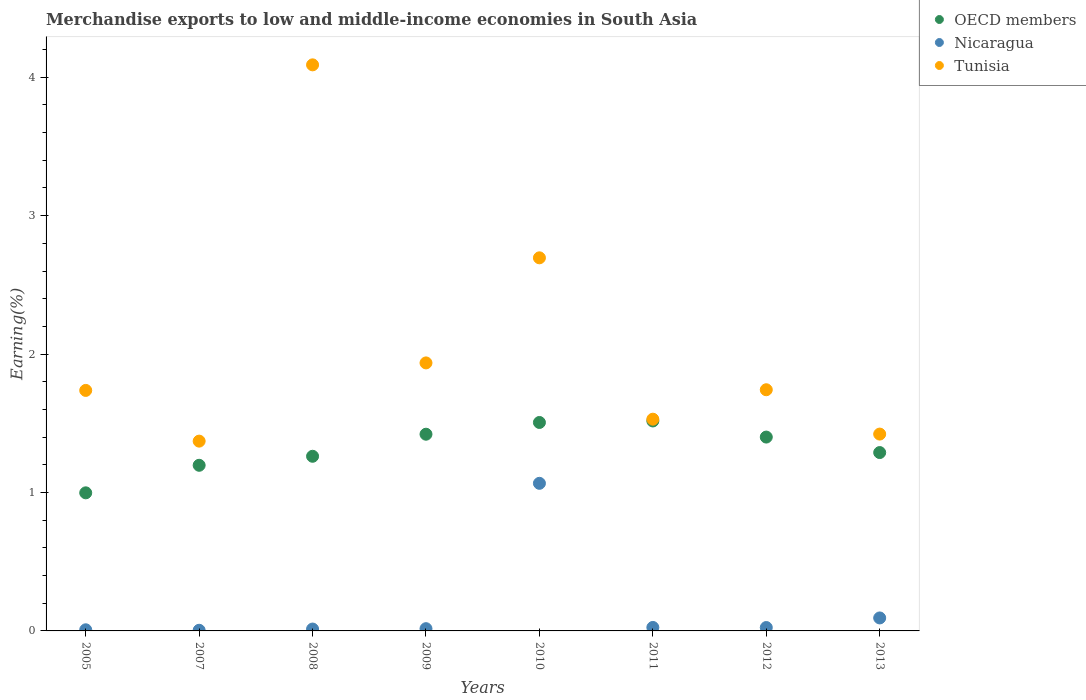How many different coloured dotlines are there?
Your answer should be compact. 3. Is the number of dotlines equal to the number of legend labels?
Keep it short and to the point. Yes. What is the percentage of amount earned from merchandise exports in Nicaragua in 2011?
Your answer should be very brief. 0.03. Across all years, what is the maximum percentage of amount earned from merchandise exports in Tunisia?
Offer a terse response. 4.09. Across all years, what is the minimum percentage of amount earned from merchandise exports in Tunisia?
Offer a terse response. 1.37. What is the total percentage of amount earned from merchandise exports in Nicaragua in the graph?
Offer a very short reply. 1.25. What is the difference between the percentage of amount earned from merchandise exports in OECD members in 2011 and that in 2012?
Provide a succinct answer. 0.12. What is the difference between the percentage of amount earned from merchandise exports in OECD members in 2007 and the percentage of amount earned from merchandise exports in Nicaragua in 2009?
Offer a terse response. 1.18. What is the average percentage of amount earned from merchandise exports in OECD members per year?
Make the answer very short. 1.32. In the year 2005, what is the difference between the percentage of amount earned from merchandise exports in Tunisia and percentage of amount earned from merchandise exports in Nicaragua?
Provide a succinct answer. 1.73. What is the ratio of the percentage of amount earned from merchandise exports in Tunisia in 2009 to that in 2013?
Offer a very short reply. 1.36. Is the difference between the percentage of amount earned from merchandise exports in Tunisia in 2009 and 2013 greater than the difference between the percentage of amount earned from merchandise exports in Nicaragua in 2009 and 2013?
Offer a terse response. Yes. What is the difference between the highest and the second highest percentage of amount earned from merchandise exports in Tunisia?
Provide a short and direct response. 1.39. What is the difference between the highest and the lowest percentage of amount earned from merchandise exports in OECD members?
Keep it short and to the point. 0.52. Does the percentage of amount earned from merchandise exports in Tunisia monotonically increase over the years?
Make the answer very short. No. Is the percentage of amount earned from merchandise exports in OECD members strictly greater than the percentage of amount earned from merchandise exports in Nicaragua over the years?
Your answer should be compact. Yes. Is the percentage of amount earned from merchandise exports in Nicaragua strictly less than the percentage of amount earned from merchandise exports in OECD members over the years?
Give a very brief answer. Yes. How many dotlines are there?
Offer a terse response. 3. How many years are there in the graph?
Your response must be concise. 8. Are the values on the major ticks of Y-axis written in scientific E-notation?
Make the answer very short. No. Does the graph contain any zero values?
Make the answer very short. No. How many legend labels are there?
Make the answer very short. 3. What is the title of the graph?
Keep it short and to the point. Merchandise exports to low and middle-income economies in South Asia. Does "France" appear as one of the legend labels in the graph?
Provide a short and direct response. No. What is the label or title of the X-axis?
Your answer should be compact. Years. What is the label or title of the Y-axis?
Ensure brevity in your answer.  Earning(%). What is the Earning(%) in OECD members in 2005?
Keep it short and to the point. 1. What is the Earning(%) of Nicaragua in 2005?
Your answer should be very brief. 0.01. What is the Earning(%) in Tunisia in 2005?
Ensure brevity in your answer.  1.74. What is the Earning(%) of OECD members in 2007?
Offer a very short reply. 1.2. What is the Earning(%) of Nicaragua in 2007?
Your answer should be compact. 0. What is the Earning(%) of Tunisia in 2007?
Make the answer very short. 1.37. What is the Earning(%) of OECD members in 2008?
Keep it short and to the point. 1.26. What is the Earning(%) of Nicaragua in 2008?
Provide a short and direct response. 0.01. What is the Earning(%) of Tunisia in 2008?
Offer a very short reply. 4.09. What is the Earning(%) of OECD members in 2009?
Ensure brevity in your answer.  1.42. What is the Earning(%) in Nicaragua in 2009?
Offer a terse response. 0.02. What is the Earning(%) in Tunisia in 2009?
Offer a very short reply. 1.94. What is the Earning(%) in OECD members in 2010?
Make the answer very short. 1.51. What is the Earning(%) of Nicaragua in 2010?
Make the answer very short. 1.07. What is the Earning(%) in Tunisia in 2010?
Make the answer very short. 2.7. What is the Earning(%) of OECD members in 2011?
Provide a succinct answer. 1.52. What is the Earning(%) in Nicaragua in 2011?
Give a very brief answer. 0.03. What is the Earning(%) in Tunisia in 2011?
Your response must be concise. 1.53. What is the Earning(%) of OECD members in 2012?
Give a very brief answer. 1.4. What is the Earning(%) in Nicaragua in 2012?
Ensure brevity in your answer.  0.02. What is the Earning(%) of Tunisia in 2012?
Your answer should be very brief. 1.74. What is the Earning(%) in OECD members in 2013?
Give a very brief answer. 1.29. What is the Earning(%) in Nicaragua in 2013?
Make the answer very short. 0.09. What is the Earning(%) in Tunisia in 2013?
Provide a short and direct response. 1.42. Across all years, what is the maximum Earning(%) in OECD members?
Offer a very short reply. 1.52. Across all years, what is the maximum Earning(%) in Nicaragua?
Your response must be concise. 1.07. Across all years, what is the maximum Earning(%) of Tunisia?
Offer a terse response. 4.09. Across all years, what is the minimum Earning(%) in OECD members?
Provide a short and direct response. 1. Across all years, what is the minimum Earning(%) in Nicaragua?
Give a very brief answer. 0. Across all years, what is the minimum Earning(%) of Tunisia?
Make the answer very short. 1.37. What is the total Earning(%) of OECD members in the graph?
Keep it short and to the point. 10.59. What is the total Earning(%) of Nicaragua in the graph?
Give a very brief answer. 1.25. What is the total Earning(%) in Tunisia in the graph?
Make the answer very short. 16.52. What is the difference between the Earning(%) of OECD members in 2005 and that in 2007?
Provide a succinct answer. -0.2. What is the difference between the Earning(%) in Nicaragua in 2005 and that in 2007?
Give a very brief answer. 0. What is the difference between the Earning(%) of Tunisia in 2005 and that in 2007?
Keep it short and to the point. 0.37. What is the difference between the Earning(%) in OECD members in 2005 and that in 2008?
Your answer should be compact. -0.26. What is the difference between the Earning(%) of Nicaragua in 2005 and that in 2008?
Your response must be concise. -0.01. What is the difference between the Earning(%) of Tunisia in 2005 and that in 2008?
Your answer should be very brief. -2.35. What is the difference between the Earning(%) of OECD members in 2005 and that in 2009?
Ensure brevity in your answer.  -0.42. What is the difference between the Earning(%) in Nicaragua in 2005 and that in 2009?
Offer a very short reply. -0.01. What is the difference between the Earning(%) of Tunisia in 2005 and that in 2009?
Your answer should be compact. -0.2. What is the difference between the Earning(%) in OECD members in 2005 and that in 2010?
Your answer should be compact. -0.51. What is the difference between the Earning(%) of Nicaragua in 2005 and that in 2010?
Ensure brevity in your answer.  -1.06. What is the difference between the Earning(%) of Tunisia in 2005 and that in 2010?
Offer a terse response. -0.96. What is the difference between the Earning(%) in OECD members in 2005 and that in 2011?
Your answer should be compact. -0.52. What is the difference between the Earning(%) in Nicaragua in 2005 and that in 2011?
Offer a very short reply. -0.02. What is the difference between the Earning(%) in Tunisia in 2005 and that in 2011?
Offer a very short reply. 0.21. What is the difference between the Earning(%) in OECD members in 2005 and that in 2012?
Keep it short and to the point. -0.4. What is the difference between the Earning(%) of Nicaragua in 2005 and that in 2012?
Give a very brief answer. -0.02. What is the difference between the Earning(%) in Tunisia in 2005 and that in 2012?
Provide a short and direct response. -0. What is the difference between the Earning(%) in OECD members in 2005 and that in 2013?
Your answer should be very brief. -0.29. What is the difference between the Earning(%) of Nicaragua in 2005 and that in 2013?
Make the answer very short. -0.09. What is the difference between the Earning(%) in Tunisia in 2005 and that in 2013?
Offer a very short reply. 0.32. What is the difference between the Earning(%) in OECD members in 2007 and that in 2008?
Offer a terse response. -0.07. What is the difference between the Earning(%) in Nicaragua in 2007 and that in 2008?
Keep it short and to the point. -0.01. What is the difference between the Earning(%) of Tunisia in 2007 and that in 2008?
Keep it short and to the point. -2.72. What is the difference between the Earning(%) in OECD members in 2007 and that in 2009?
Make the answer very short. -0.22. What is the difference between the Earning(%) in Nicaragua in 2007 and that in 2009?
Provide a succinct answer. -0.01. What is the difference between the Earning(%) in Tunisia in 2007 and that in 2009?
Your answer should be compact. -0.57. What is the difference between the Earning(%) in OECD members in 2007 and that in 2010?
Offer a very short reply. -0.31. What is the difference between the Earning(%) of Nicaragua in 2007 and that in 2010?
Make the answer very short. -1.06. What is the difference between the Earning(%) of Tunisia in 2007 and that in 2010?
Your response must be concise. -1.32. What is the difference between the Earning(%) in OECD members in 2007 and that in 2011?
Offer a very short reply. -0.32. What is the difference between the Earning(%) in Nicaragua in 2007 and that in 2011?
Make the answer very short. -0.02. What is the difference between the Earning(%) of Tunisia in 2007 and that in 2011?
Keep it short and to the point. -0.16. What is the difference between the Earning(%) of OECD members in 2007 and that in 2012?
Your answer should be compact. -0.2. What is the difference between the Earning(%) in Nicaragua in 2007 and that in 2012?
Give a very brief answer. -0.02. What is the difference between the Earning(%) of Tunisia in 2007 and that in 2012?
Ensure brevity in your answer.  -0.37. What is the difference between the Earning(%) of OECD members in 2007 and that in 2013?
Offer a very short reply. -0.09. What is the difference between the Earning(%) in Nicaragua in 2007 and that in 2013?
Make the answer very short. -0.09. What is the difference between the Earning(%) of Tunisia in 2007 and that in 2013?
Provide a short and direct response. -0.05. What is the difference between the Earning(%) of OECD members in 2008 and that in 2009?
Provide a succinct answer. -0.16. What is the difference between the Earning(%) in Nicaragua in 2008 and that in 2009?
Your response must be concise. -0. What is the difference between the Earning(%) of Tunisia in 2008 and that in 2009?
Your response must be concise. 2.15. What is the difference between the Earning(%) in OECD members in 2008 and that in 2010?
Ensure brevity in your answer.  -0.24. What is the difference between the Earning(%) in Nicaragua in 2008 and that in 2010?
Your answer should be compact. -1.05. What is the difference between the Earning(%) in Tunisia in 2008 and that in 2010?
Provide a succinct answer. 1.39. What is the difference between the Earning(%) in OECD members in 2008 and that in 2011?
Ensure brevity in your answer.  -0.26. What is the difference between the Earning(%) of Nicaragua in 2008 and that in 2011?
Provide a short and direct response. -0.01. What is the difference between the Earning(%) in Tunisia in 2008 and that in 2011?
Your response must be concise. 2.56. What is the difference between the Earning(%) of OECD members in 2008 and that in 2012?
Your answer should be very brief. -0.14. What is the difference between the Earning(%) of Nicaragua in 2008 and that in 2012?
Give a very brief answer. -0.01. What is the difference between the Earning(%) of Tunisia in 2008 and that in 2012?
Offer a very short reply. 2.35. What is the difference between the Earning(%) in OECD members in 2008 and that in 2013?
Your response must be concise. -0.03. What is the difference between the Earning(%) in Nicaragua in 2008 and that in 2013?
Provide a succinct answer. -0.08. What is the difference between the Earning(%) in Tunisia in 2008 and that in 2013?
Keep it short and to the point. 2.67. What is the difference between the Earning(%) in OECD members in 2009 and that in 2010?
Offer a very short reply. -0.08. What is the difference between the Earning(%) of Nicaragua in 2009 and that in 2010?
Your answer should be compact. -1.05. What is the difference between the Earning(%) of Tunisia in 2009 and that in 2010?
Your response must be concise. -0.76. What is the difference between the Earning(%) of OECD members in 2009 and that in 2011?
Give a very brief answer. -0.1. What is the difference between the Earning(%) of Nicaragua in 2009 and that in 2011?
Your answer should be very brief. -0.01. What is the difference between the Earning(%) of Tunisia in 2009 and that in 2011?
Give a very brief answer. 0.41. What is the difference between the Earning(%) in OECD members in 2009 and that in 2012?
Your response must be concise. 0.02. What is the difference between the Earning(%) in Nicaragua in 2009 and that in 2012?
Give a very brief answer. -0.01. What is the difference between the Earning(%) of Tunisia in 2009 and that in 2012?
Give a very brief answer. 0.19. What is the difference between the Earning(%) of OECD members in 2009 and that in 2013?
Your answer should be very brief. 0.13. What is the difference between the Earning(%) in Nicaragua in 2009 and that in 2013?
Offer a terse response. -0.08. What is the difference between the Earning(%) of Tunisia in 2009 and that in 2013?
Your answer should be very brief. 0.51. What is the difference between the Earning(%) in OECD members in 2010 and that in 2011?
Offer a terse response. -0.01. What is the difference between the Earning(%) of Nicaragua in 2010 and that in 2011?
Give a very brief answer. 1.04. What is the difference between the Earning(%) of Tunisia in 2010 and that in 2011?
Keep it short and to the point. 1.17. What is the difference between the Earning(%) of OECD members in 2010 and that in 2012?
Offer a very short reply. 0.11. What is the difference between the Earning(%) in Nicaragua in 2010 and that in 2012?
Your answer should be very brief. 1.04. What is the difference between the Earning(%) in Tunisia in 2010 and that in 2012?
Keep it short and to the point. 0.95. What is the difference between the Earning(%) of OECD members in 2010 and that in 2013?
Offer a terse response. 0.22. What is the difference between the Earning(%) of Nicaragua in 2010 and that in 2013?
Your answer should be compact. 0.97. What is the difference between the Earning(%) in Tunisia in 2010 and that in 2013?
Ensure brevity in your answer.  1.27. What is the difference between the Earning(%) of OECD members in 2011 and that in 2012?
Your response must be concise. 0.12. What is the difference between the Earning(%) in Nicaragua in 2011 and that in 2012?
Provide a short and direct response. 0. What is the difference between the Earning(%) in Tunisia in 2011 and that in 2012?
Your answer should be compact. -0.21. What is the difference between the Earning(%) in OECD members in 2011 and that in 2013?
Your answer should be compact. 0.23. What is the difference between the Earning(%) of Nicaragua in 2011 and that in 2013?
Offer a terse response. -0.07. What is the difference between the Earning(%) in Tunisia in 2011 and that in 2013?
Give a very brief answer. 0.11. What is the difference between the Earning(%) of OECD members in 2012 and that in 2013?
Your answer should be very brief. 0.11. What is the difference between the Earning(%) of Nicaragua in 2012 and that in 2013?
Make the answer very short. -0.07. What is the difference between the Earning(%) in Tunisia in 2012 and that in 2013?
Provide a short and direct response. 0.32. What is the difference between the Earning(%) in OECD members in 2005 and the Earning(%) in Nicaragua in 2007?
Your answer should be very brief. 0.99. What is the difference between the Earning(%) of OECD members in 2005 and the Earning(%) of Tunisia in 2007?
Ensure brevity in your answer.  -0.37. What is the difference between the Earning(%) of Nicaragua in 2005 and the Earning(%) of Tunisia in 2007?
Keep it short and to the point. -1.36. What is the difference between the Earning(%) of OECD members in 2005 and the Earning(%) of Tunisia in 2008?
Your answer should be compact. -3.09. What is the difference between the Earning(%) in Nicaragua in 2005 and the Earning(%) in Tunisia in 2008?
Your answer should be compact. -4.08. What is the difference between the Earning(%) in OECD members in 2005 and the Earning(%) in Nicaragua in 2009?
Keep it short and to the point. 0.98. What is the difference between the Earning(%) in OECD members in 2005 and the Earning(%) in Tunisia in 2009?
Your response must be concise. -0.94. What is the difference between the Earning(%) of Nicaragua in 2005 and the Earning(%) of Tunisia in 2009?
Give a very brief answer. -1.93. What is the difference between the Earning(%) of OECD members in 2005 and the Earning(%) of Nicaragua in 2010?
Provide a short and direct response. -0.07. What is the difference between the Earning(%) of OECD members in 2005 and the Earning(%) of Tunisia in 2010?
Your answer should be compact. -1.7. What is the difference between the Earning(%) of Nicaragua in 2005 and the Earning(%) of Tunisia in 2010?
Offer a terse response. -2.69. What is the difference between the Earning(%) in OECD members in 2005 and the Earning(%) in Nicaragua in 2011?
Your answer should be very brief. 0.97. What is the difference between the Earning(%) in OECD members in 2005 and the Earning(%) in Tunisia in 2011?
Your response must be concise. -0.53. What is the difference between the Earning(%) in Nicaragua in 2005 and the Earning(%) in Tunisia in 2011?
Your answer should be very brief. -1.52. What is the difference between the Earning(%) in OECD members in 2005 and the Earning(%) in Nicaragua in 2012?
Your answer should be very brief. 0.97. What is the difference between the Earning(%) of OECD members in 2005 and the Earning(%) of Tunisia in 2012?
Your response must be concise. -0.74. What is the difference between the Earning(%) of Nicaragua in 2005 and the Earning(%) of Tunisia in 2012?
Your answer should be very brief. -1.73. What is the difference between the Earning(%) in OECD members in 2005 and the Earning(%) in Nicaragua in 2013?
Make the answer very short. 0.9. What is the difference between the Earning(%) in OECD members in 2005 and the Earning(%) in Tunisia in 2013?
Ensure brevity in your answer.  -0.42. What is the difference between the Earning(%) of Nicaragua in 2005 and the Earning(%) of Tunisia in 2013?
Your answer should be compact. -1.41. What is the difference between the Earning(%) of OECD members in 2007 and the Earning(%) of Nicaragua in 2008?
Your answer should be compact. 1.18. What is the difference between the Earning(%) in OECD members in 2007 and the Earning(%) in Tunisia in 2008?
Make the answer very short. -2.89. What is the difference between the Earning(%) of Nicaragua in 2007 and the Earning(%) of Tunisia in 2008?
Offer a terse response. -4.08. What is the difference between the Earning(%) of OECD members in 2007 and the Earning(%) of Nicaragua in 2009?
Your response must be concise. 1.18. What is the difference between the Earning(%) in OECD members in 2007 and the Earning(%) in Tunisia in 2009?
Your response must be concise. -0.74. What is the difference between the Earning(%) in Nicaragua in 2007 and the Earning(%) in Tunisia in 2009?
Your response must be concise. -1.93. What is the difference between the Earning(%) of OECD members in 2007 and the Earning(%) of Nicaragua in 2010?
Ensure brevity in your answer.  0.13. What is the difference between the Earning(%) of OECD members in 2007 and the Earning(%) of Tunisia in 2010?
Provide a succinct answer. -1.5. What is the difference between the Earning(%) of Nicaragua in 2007 and the Earning(%) of Tunisia in 2010?
Your response must be concise. -2.69. What is the difference between the Earning(%) in OECD members in 2007 and the Earning(%) in Nicaragua in 2011?
Your answer should be compact. 1.17. What is the difference between the Earning(%) in OECD members in 2007 and the Earning(%) in Tunisia in 2011?
Offer a very short reply. -0.33. What is the difference between the Earning(%) in Nicaragua in 2007 and the Earning(%) in Tunisia in 2011?
Keep it short and to the point. -1.52. What is the difference between the Earning(%) in OECD members in 2007 and the Earning(%) in Nicaragua in 2012?
Your answer should be compact. 1.17. What is the difference between the Earning(%) in OECD members in 2007 and the Earning(%) in Tunisia in 2012?
Provide a short and direct response. -0.55. What is the difference between the Earning(%) of Nicaragua in 2007 and the Earning(%) of Tunisia in 2012?
Provide a short and direct response. -1.74. What is the difference between the Earning(%) in OECD members in 2007 and the Earning(%) in Nicaragua in 2013?
Give a very brief answer. 1.1. What is the difference between the Earning(%) of OECD members in 2007 and the Earning(%) of Tunisia in 2013?
Offer a very short reply. -0.23. What is the difference between the Earning(%) in Nicaragua in 2007 and the Earning(%) in Tunisia in 2013?
Your answer should be very brief. -1.42. What is the difference between the Earning(%) of OECD members in 2008 and the Earning(%) of Nicaragua in 2009?
Keep it short and to the point. 1.25. What is the difference between the Earning(%) of OECD members in 2008 and the Earning(%) of Tunisia in 2009?
Provide a succinct answer. -0.67. What is the difference between the Earning(%) of Nicaragua in 2008 and the Earning(%) of Tunisia in 2009?
Your answer should be compact. -1.92. What is the difference between the Earning(%) of OECD members in 2008 and the Earning(%) of Nicaragua in 2010?
Offer a terse response. 0.2. What is the difference between the Earning(%) of OECD members in 2008 and the Earning(%) of Tunisia in 2010?
Make the answer very short. -1.43. What is the difference between the Earning(%) of Nicaragua in 2008 and the Earning(%) of Tunisia in 2010?
Make the answer very short. -2.68. What is the difference between the Earning(%) of OECD members in 2008 and the Earning(%) of Nicaragua in 2011?
Give a very brief answer. 1.24. What is the difference between the Earning(%) of OECD members in 2008 and the Earning(%) of Tunisia in 2011?
Your answer should be compact. -0.27. What is the difference between the Earning(%) of Nicaragua in 2008 and the Earning(%) of Tunisia in 2011?
Keep it short and to the point. -1.52. What is the difference between the Earning(%) of OECD members in 2008 and the Earning(%) of Nicaragua in 2012?
Your response must be concise. 1.24. What is the difference between the Earning(%) in OECD members in 2008 and the Earning(%) in Tunisia in 2012?
Make the answer very short. -0.48. What is the difference between the Earning(%) of Nicaragua in 2008 and the Earning(%) of Tunisia in 2012?
Provide a succinct answer. -1.73. What is the difference between the Earning(%) of OECD members in 2008 and the Earning(%) of Nicaragua in 2013?
Offer a very short reply. 1.17. What is the difference between the Earning(%) of OECD members in 2008 and the Earning(%) of Tunisia in 2013?
Keep it short and to the point. -0.16. What is the difference between the Earning(%) of Nicaragua in 2008 and the Earning(%) of Tunisia in 2013?
Your answer should be very brief. -1.41. What is the difference between the Earning(%) of OECD members in 2009 and the Earning(%) of Nicaragua in 2010?
Provide a succinct answer. 0.35. What is the difference between the Earning(%) of OECD members in 2009 and the Earning(%) of Tunisia in 2010?
Ensure brevity in your answer.  -1.27. What is the difference between the Earning(%) in Nicaragua in 2009 and the Earning(%) in Tunisia in 2010?
Offer a terse response. -2.68. What is the difference between the Earning(%) of OECD members in 2009 and the Earning(%) of Nicaragua in 2011?
Your answer should be very brief. 1.4. What is the difference between the Earning(%) of OECD members in 2009 and the Earning(%) of Tunisia in 2011?
Offer a very short reply. -0.11. What is the difference between the Earning(%) of Nicaragua in 2009 and the Earning(%) of Tunisia in 2011?
Give a very brief answer. -1.51. What is the difference between the Earning(%) of OECD members in 2009 and the Earning(%) of Nicaragua in 2012?
Give a very brief answer. 1.4. What is the difference between the Earning(%) of OECD members in 2009 and the Earning(%) of Tunisia in 2012?
Your response must be concise. -0.32. What is the difference between the Earning(%) in Nicaragua in 2009 and the Earning(%) in Tunisia in 2012?
Your answer should be very brief. -1.73. What is the difference between the Earning(%) of OECD members in 2009 and the Earning(%) of Nicaragua in 2013?
Give a very brief answer. 1.33. What is the difference between the Earning(%) of OECD members in 2009 and the Earning(%) of Tunisia in 2013?
Your answer should be very brief. -0. What is the difference between the Earning(%) of Nicaragua in 2009 and the Earning(%) of Tunisia in 2013?
Ensure brevity in your answer.  -1.41. What is the difference between the Earning(%) of OECD members in 2010 and the Earning(%) of Nicaragua in 2011?
Make the answer very short. 1.48. What is the difference between the Earning(%) of OECD members in 2010 and the Earning(%) of Tunisia in 2011?
Offer a very short reply. -0.02. What is the difference between the Earning(%) of Nicaragua in 2010 and the Earning(%) of Tunisia in 2011?
Offer a terse response. -0.46. What is the difference between the Earning(%) of OECD members in 2010 and the Earning(%) of Nicaragua in 2012?
Keep it short and to the point. 1.48. What is the difference between the Earning(%) in OECD members in 2010 and the Earning(%) in Tunisia in 2012?
Make the answer very short. -0.24. What is the difference between the Earning(%) in Nicaragua in 2010 and the Earning(%) in Tunisia in 2012?
Offer a very short reply. -0.68. What is the difference between the Earning(%) in OECD members in 2010 and the Earning(%) in Nicaragua in 2013?
Ensure brevity in your answer.  1.41. What is the difference between the Earning(%) in OECD members in 2010 and the Earning(%) in Tunisia in 2013?
Offer a terse response. 0.08. What is the difference between the Earning(%) in Nicaragua in 2010 and the Earning(%) in Tunisia in 2013?
Give a very brief answer. -0.36. What is the difference between the Earning(%) of OECD members in 2011 and the Earning(%) of Nicaragua in 2012?
Ensure brevity in your answer.  1.49. What is the difference between the Earning(%) of OECD members in 2011 and the Earning(%) of Tunisia in 2012?
Your answer should be very brief. -0.23. What is the difference between the Earning(%) in Nicaragua in 2011 and the Earning(%) in Tunisia in 2012?
Provide a short and direct response. -1.72. What is the difference between the Earning(%) of OECD members in 2011 and the Earning(%) of Nicaragua in 2013?
Ensure brevity in your answer.  1.42. What is the difference between the Earning(%) of OECD members in 2011 and the Earning(%) of Tunisia in 2013?
Your answer should be very brief. 0.09. What is the difference between the Earning(%) in Nicaragua in 2011 and the Earning(%) in Tunisia in 2013?
Your answer should be very brief. -1.4. What is the difference between the Earning(%) of OECD members in 2012 and the Earning(%) of Nicaragua in 2013?
Give a very brief answer. 1.31. What is the difference between the Earning(%) in OECD members in 2012 and the Earning(%) in Tunisia in 2013?
Offer a terse response. -0.02. What is the difference between the Earning(%) of Nicaragua in 2012 and the Earning(%) of Tunisia in 2013?
Your answer should be compact. -1.4. What is the average Earning(%) of OECD members per year?
Make the answer very short. 1.32. What is the average Earning(%) of Nicaragua per year?
Offer a very short reply. 0.16. What is the average Earning(%) in Tunisia per year?
Give a very brief answer. 2.07. In the year 2005, what is the difference between the Earning(%) of OECD members and Earning(%) of Tunisia?
Your response must be concise. -0.74. In the year 2005, what is the difference between the Earning(%) in Nicaragua and Earning(%) in Tunisia?
Provide a succinct answer. -1.73. In the year 2007, what is the difference between the Earning(%) of OECD members and Earning(%) of Nicaragua?
Your response must be concise. 1.19. In the year 2007, what is the difference between the Earning(%) in OECD members and Earning(%) in Tunisia?
Provide a succinct answer. -0.17. In the year 2007, what is the difference between the Earning(%) of Nicaragua and Earning(%) of Tunisia?
Give a very brief answer. -1.37. In the year 2008, what is the difference between the Earning(%) in OECD members and Earning(%) in Nicaragua?
Give a very brief answer. 1.25. In the year 2008, what is the difference between the Earning(%) in OECD members and Earning(%) in Tunisia?
Give a very brief answer. -2.83. In the year 2008, what is the difference between the Earning(%) in Nicaragua and Earning(%) in Tunisia?
Offer a very short reply. -4.08. In the year 2009, what is the difference between the Earning(%) of OECD members and Earning(%) of Nicaragua?
Your answer should be very brief. 1.4. In the year 2009, what is the difference between the Earning(%) in OECD members and Earning(%) in Tunisia?
Keep it short and to the point. -0.52. In the year 2009, what is the difference between the Earning(%) in Nicaragua and Earning(%) in Tunisia?
Your response must be concise. -1.92. In the year 2010, what is the difference between the Earning(%) in OECD members and Earning(%) in Nicaragua?
Keep it short and to the point. 0.44. In the year 2010, what is the difference between the Earning(%) in OECD members and Earning(%) in Tunisia?
Keep it short and to the point. -1.19. In the year 2010, what is the difference between the Earning(%) of Nicaragua and Earning(%) of Tunisia?
Give a very brief answer. -1.63. In the year 2011, what is the difference between the Earning(%) in OECD members and Earning(%) in Nicaragua?
Provide a succinct answer. 1.49. In the year 2011, what is the difference between the Earning(%) in OECD members and Earning(%) in Tunisia?
Offer a terse response. -0.01. In the year 2011, what is the difference between the Earning(%) in Nicaragua and Earning(%) in Tunisia?
Ensure brevity in your answer.  -1.5. In the year 2012, what is the difference between the Earning(%) of OECD members and Earning(%) of Nicaragua?
Provide a succinct answer. 1.38. In the year 2012, what is the difference between the Earning(%) of OECD members and Earning(%) of Tunisia?
Your answer should be very brief. -0.34. In the year 2012, what is the difference between the Earning(%) in Nicaragua and Earning(%) in Tunisia?
Make the answer very short. -1.72. In the year 2013, what is the difference between the Earning(%) in OECD members and Earning(%) in Nicaragua?
Make the answer very short. 1.19. In the year 2013, what is the difference between the Earning(%) in OECD members and Earning(%) in Tunisia?
Offer a terse response. -0.13. In the year 2013, what is the difference between the Earning(%) of Nicaragua and Earning(%) of Tunisia?
Give a very brief answer. -1.33. What is the ratio of the Earning(%) of OECD members in 2005 to that in 2007?
Your response must be concise. 0.83. What is the ratio of the Earning(%) of Nicaragua in 2005 to that in 2007?
Provide a succinct answer. 1.75. What is the ratio of the Earning(%) of Tunisia in 2005 to that in 2007?
Keep it short and to the point. 1.27. What is the ratio of the Earning(%) in OECD members in 2005 to that in 2008?
Keep it short and to the point. 0.79. What is the ratio of the Earning(%) of Nicaragua in 2005 to that in 2008?
Give a very brief answer. 0.6. What is the ratio of the Earning(%) in Tunisia in 2005 to that in 2008?
Keep it short and to the point. 0.42. What is the ratio of the Earning(%) in OECD members in 2005 to that in 2009?
Your answer should be compact. 0.7. What is the ratio of the Earning(%) of Nicaragua in 2005 to that in 2009?
Make the answer very short. 0.5. What is the ratio of the Earning(%) of Tunisia in 2005 to that in 2009?
Offer a terse response. 0.9. What is the ratio of the Earning(%) in OECD members in 2005 to that in 2010?
Your answer should be compact. 0.66. What is the ratio of the Earning(%) in Nicaragua in 2005 to that in 2010?
Provide a short and direct response. 0.01. What is the ratio of the Earning(%) of Tunisia in 2005 to that in 2010?
Keep it short and to the point. 0.64. What is the ratio of the Earning(%) of OECD members in 2005 to that in 2011?
Make the answer very short. 0.66. What is the ratio of the Earning(%) in Nicaragua in 2005 to that in 2011?
Give a very brief answer. 0.33. What is the ratio of the Earning(%) in Tunisia in 2005 to that in 2011?
Provide a short and direct response. 1.14. What is the ratio of the Earning(%) in OECD members in 2005 to that in 2012?
Keep it short and to the point. 0.71. What is the ratio of the Earning(%) of Nicaragua in 2005 to that in 2012?
Offer a very short reply. 0.33. What is the ratio of the Earning(%) of Tunisia in 2005 to that in 2012?
Make the answer very short. 1. What is the ratio of the Earning(%) of OECD members in 2005 to that in 2013?
Your answer should be very brief. 0.77. What is the ratio of the Earning(%) in Nicaragua in 2005 to that in 2013?
Offer a very short reply. 0.09. What is the ratio of the Earning(%) of Tunisia in 2005 to that in 2013?
Your answer should be very brief. 1.22. What is the ratio of the Earning(%) in OECD members in 2007 to that in 2008?
Your response must be concise. 0.95. What is the ratio of the Earning(%) of Nicaragua in 2007 to that in 2008?
Your response must be concise. 0.35. What is the ratio of the Earning(%) in Tunisia in 2007 to that in 2008?
Keep it short and to the point. 0.34. What is the ratio of the Earning(%) of OECD members in 2007 to that in 2009?
Provide a short and direct response. 0.84. What is the ratio of the Earning(%) of Nicaragua in 2007 to that in 2009?
Ensure brevity in your answer.  0.29. What is the ratio of the Earning(%) of Tunisia in 2007 to that in 2009?
Your answer should be compact. 0.71. What is the ratio of the Earning(%) in OECD members in 2007 to that in 2010?
Provide a succinct answer. 0.79. What is the ratio of the Earning(%) in Nicaragua in 2007 to that in 2010?
Offer a very short reply. 0. What is the ratio of the Earning(%) of Tunisia in 2007 to that in 2010?
Offer a very short reply. 0.51. What is the ratio of the Earning(%) in OECD members in 2007 to that in 2011?
Ensure brevity in your answer.  0.79. What is the ratio of the Earning(%) of Nicaragua in 2007 to that in 2011?
Give a very brief answer. 0.19. What is the ratio of the Earning(%) of Tunisia in 2007 to that in 2011?
Your answer should be compact. 0.9. What is the ratio of the Earning(%) of OECD members in 2007 to that in 2012?
Ensure brevity in your answer.  0.85. What is the ratio of the Earning(%) in Nicaragua in 2007 to that in 2012?
Make the answer very short. 0.19. What is the ratio of the Earning(%) of Tunisia in 2007 to that in 2012?
Provide a short and direct response. 0.79. What is the ratio of the Earning(%) in Nicaragua in 2007 to that in 2013?
Offer a very short reply. 0.05. What is the ratio of the Earning(%) in Tunisia in 2007 to that in 2013?
Provide a succinct answer. 0.96. What is the ratio of the Earning(%) of OECD members in 2008 to that in 2009?
Your answer should be compact. 0.89. What is the ratio of the Earning(%) of Nicaragua in 2008 to that in 2009?
Make the answer very short. 0.84. What is the ratio of the Earning(%) of Tunisia in 2008 to that in 2009?
Ensure brevity in your answer.  2.11. What is the ratio of the Earning(%) of OECD members in 2008 to that in 2010?
Offer a terse response. 0.84. What is the ratio of the Earning(%) in Nicaragua in 2008 to that in 2010?
Your answer should be compact. 0.01. What is the ratio of the Earning(%) of Tunisia in 2008 to that in 2010?
Provide a short and direct response. 1.52. What is the ratio of the Earning(%) of OECD members in 2008 to that in 2011?
Offer a terse response. 0.83. What is the ratio of the Earning(%) of Nicaragua in 2008 to that in 2011?
Give a very brief answer. 0.54. What is the ratio of the Earning(%) of Tunisia in 2008 to that in 2011?
Offer a very short reply. 2.67. What is the ratio of the Earning(%) in OECD members in 2008 to that in 2012?
Provide a short and direct response. 0.9. What is the ratio of the Earning(%) of Nicaragua in 2008 to that in 2012?
Offer a very short reply. 0.55. What is the ratio of the Earning(%) in Tunisia in 2008 to that in 2012?
Your answer should be compact. 2.35. What is the ratio of the Earning(%) of OECD members in 2008 to that in 2013?
Ensure brevity in your answer.  0.98. What is the ratio of the Earning(%) of Nicaragua in 2008 to that in 2013?
Your answer should be compact. 0.14. What is the ratio of the Earning(%) of Tunisia in 2008 to that in 2013?
Your answer should be very brief. 2.88. What is the ratio of the Earning(%) in OECD members in 2009 to that in 2010?
Ensure brevity in your answer.  0.94. What is the ratio of the Earning(%) in Nicaragua in 2009 to that in 2010?
Provide a succinct answer. 0.02. What is the ratio of the Earning(%) of Tunisia in 2009 to that in 2010?
Offer a terse response. 0.72. What is the ratio of the Earning(%) in OECD members in 2009 to that in 2011?
Ensure brevity in your answer.  0.94. What is the ratio of the Earning(%) in Nicaragua in 2009 to that in 2011?
Offer a terse response. 0.65. What is the ratio of the Earning(%) in Tunisia in 2009 to that in 2011?
Ensure brevity in your answer.  1.27. What is the ratio of the Earning(%) in OECD members in 2009 to that in 2012?
Keep it short and to the point. 1.01. What is the ratio of the Earning(%) in Nicaragua in 2009 to that in 2012?
Offer a very short reply. 0.66. What is the ratio of the Earning(%) of Tunisia in 2009 to that in 2012?
Ensure brevity in your answer.  1.11. What is the ratio of the Earning(%) in OECD members in 2009 to that in 2013?
Offer a very short reply. 1.1. What is the ratio of the Earning(%) of Nicaragua in 2009 to that in 2013?
Offer a very short reply. 0.17. What is the ratio of the Earning(%) in Tunisia in 2009 to that in 2013?
Give a very brief answer. 1.36. What is the ratio of the Earning(%) of Nicaragua in 2010 to that in 2011?
Give a very brief answer. 42.47. What is the ratio of the Earning(%) of Tunisia in 2010 to that in 2011?
Ensure brevity in your answer.  1.76. What is the ratio of the Earning(%) of OECD members in 2010 to that in 2012?
Give a very brief answer. 1.08. What is the ratio of the Earning(%) of Nicaragua in 2010 to that in 2012?
Keep it short and to the point. 43.65. What is the ratio of the Earning(%) in Tunisia in 2010 to that in 2012?
Offer a very short reply. 1.55. What is the ratio of the Earning(%) of OECD members in 2010 to that in 2013?
Give a very brief answer. 1.17. What is the ratio of the Earning(%) of Nicaragua in 2010 to that in 2013?
Provide a short and direct response. 11.37. What is the ratio of the Earning(%) in Tunisia in 2010 to that in 2013?
Give a very brief answer. 1.9. What is the ratio of the Earning(%) in OECD members in 2011 to that in 2012?
Your response must be concise. 1.08. What is the ratio of the Earning(%) of Nicaragua in 2011 to that in 2012?
Provide a short and direct response. 1.03. What is the ratio of the Earning(%) in Tunisia in 2011 to that in 2012?
Your response must be concise. 0.88. What is the ratio of the Earning(%) in OECD members in 2011 to that in 2013?
Your answer should be compact. 1.18. What is the ratio of the Earning(%) of Nicaragua in 2011 to that in 2013?
Make the answer very short. 0.27. What is the ratio of the Earning(%) of Tunisia in 2011 to that in 2013?
Offer a very short reply. 1.08. What is the ratio of the Earning(%) of OECD members in 2012 to that in 2013?
Offer a terse response. 1.09. What is the ratio of the Earning(%) in Nicaragua in 2012 to that in 2013?
Offer a very short reply. 0.26. What is the ratio of the Earning(%) in Tunisia in 2012 to that in 2013?
Your answer should be very brief. 1.23. What is the difference between the highest and the second highest Earning(%) of OECD members?
Provide a succinct answer. 0.01. What is the difference between the highest and the second highest Earning(%) of Nicaragua?
Provide a succinct answer. 0.97. What is the difference between the highest and the second highest Earning(%) in Tunisia?
Provide a short and direct response. 1.39. What is the difference between the highest and the lowest Earning(%) in OECD members?
Give a very brief answer. 0.52. What is the difference between the highest and the lowest Earning(%) in Nicaragua?
Offer a very short reply. 1.06. What is the difference between the highest and the lowest Earning(%) in Tunisia?
Give a very brief answer. 2.72. 